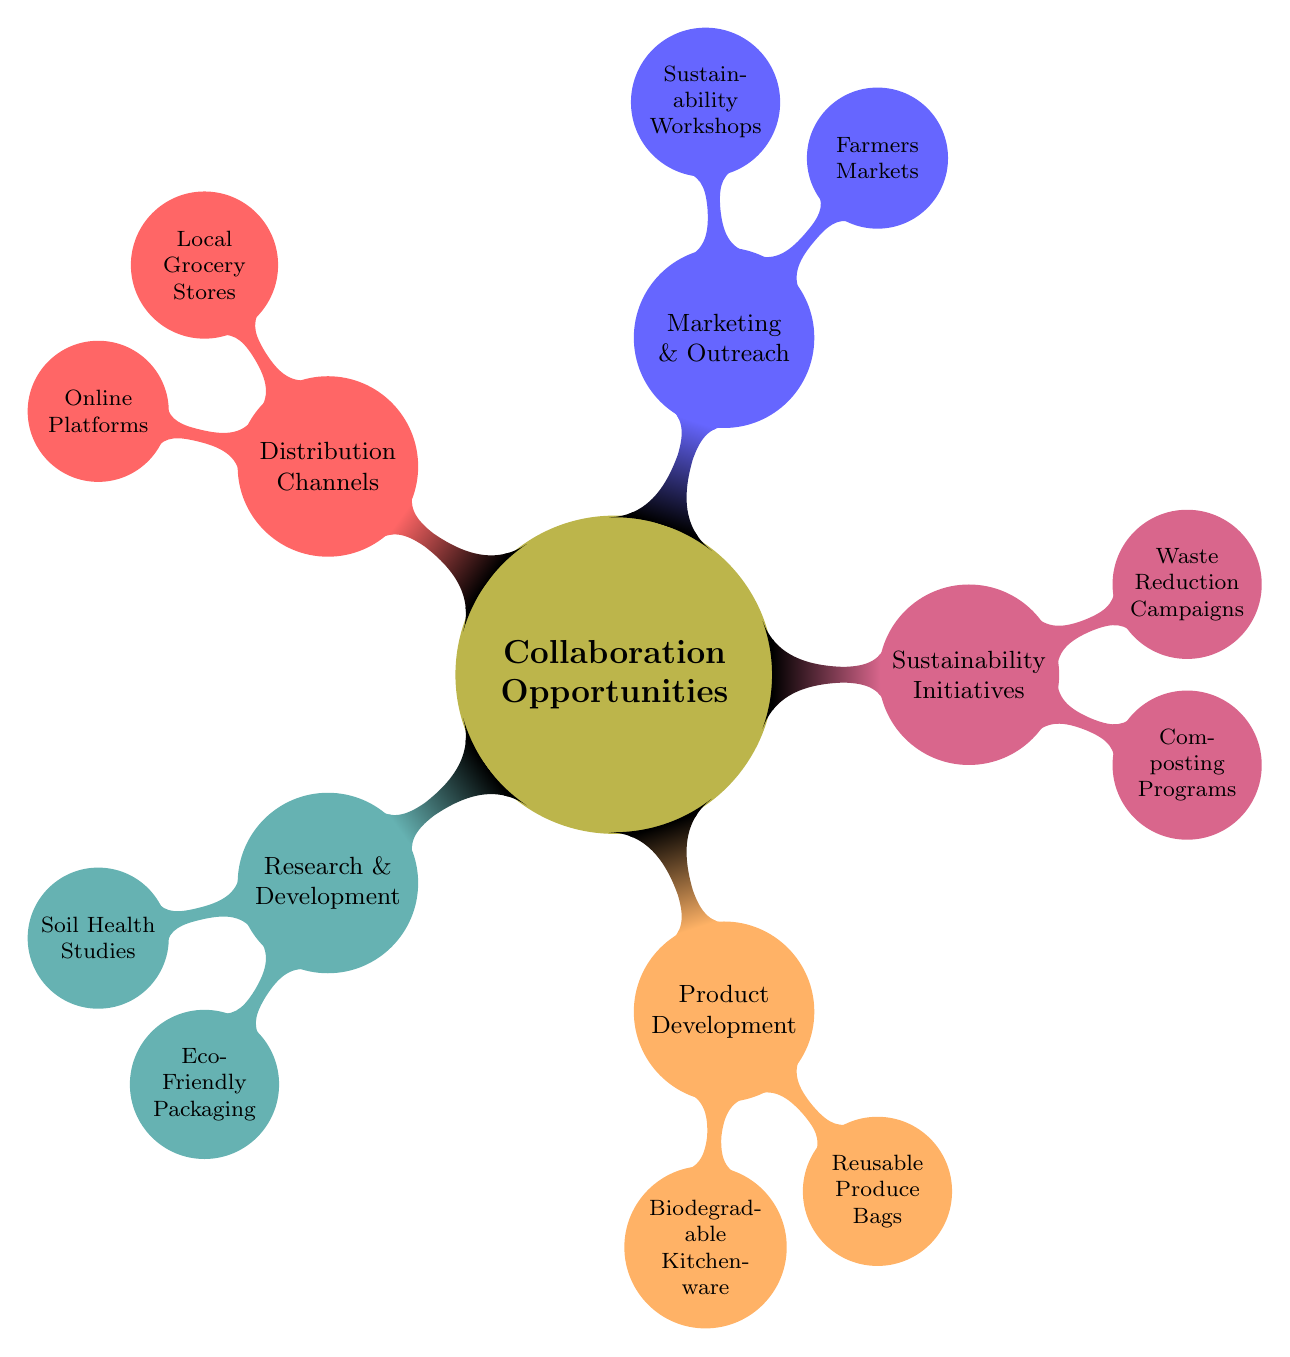What are the two main categories under which eco-friendly packaging is listed? Eco-Friendly Packaging is categorized under the Research and Development section of the mind map. Therefore, the two main categories that encompass this item would be "Research and Development" and "Eco-Friendly Packaging".
Answer: Research and Development, Eco-Friendly Packaging How many nodes are there under the Sustainability Initiatives category? By examining the Sustainability Initiatives category, we see that it has two child nodes: Composting Programs and Waste Reduction Campaigns. Hence, the total count is two nodes under this category.
Answer: 2 Which category includes Reusable Produce Bags? Reusable Produce Bags is listed as a child node under the Product Development category. Thus, the category associated with this item is Product Development.
Answer: Product Development What type of workshops are included in Marketing and Outreach? The Marketing and Outreach category lists Sustainability Workshops as one of its child nodes, indicating that this type of workshop is included within that category.
Answer: Sustainability Workshops How is the collaboration in distribution channels structured? Distribution Channels contain two distinct nodes: Local Grocery Stores and Online Platforms. This indicates that the collaboration in this section is directed towards two specific methods of distribution within the community.
Answer: Local Grocery Stores, Online Platforms What connections are there between Soil Health Studies and Composting Programs? Both Soil Health Studies and Composting Programs are linked through their common goal of enhancing soil sustainability, although they belong to different main categories: Research and Development, and Sustainability Initiatives respectively.
Answer: Enhancing soil sustainability How many categories focus specifically on developing new products? The mind map highlights that there is one category solely dedicated to developing new products, which is the Product Development category.
Answer: 1 Which organization is linked to Farmers Markets in the Marketing and Outreach section? In the Marketing and Outreach section, the child node Farmers Markets is associated with the Community Farm Co-op, indicating this partnership focus within that area of outreach.
Answer: Community Farm Co-op Which category connects to Urban Compost Collective? Urban Compost Collective is specifically linked under the Sustainability Initiatives category. Hence, the connection to this organization is through Sustainability Initiatives.
Answer: Sustainability Initiatives 